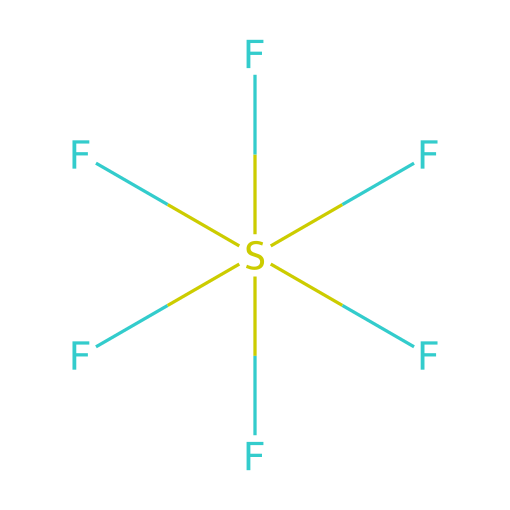What is the name of this chemical? The structure represents a compound with one sulfur atom and six fluorine atoms bonded to it. The distinct arrangement of these atoms corresponds to sulfur hexafluoride.
Answer: sulfur hexafluoride How many fluorine atoms are present? The SMILES representation clearly shows six fluorine atoms surrounding a single sulfur atom. This can be counted directly from the formula.
Answer: six What type of bond exists between sulfur and fluorine? The sulfur atom is covalently bonded to each of the six fluorine atoms, resulting in strong bonds characterized by the sharing of electrons.
Answer: covalent bond What geometry does sulfur hexafluoride exhibit? In sulfur hexafluoride, the arrangement of the six fluorine atoms around the sulfur atom leads to an octahedral geometry, which can be inferred from the bonding pattern.
Answer: octahedral Why is sulfur hexafluoride used in audio equipment? The large molecular size and low reactivity of sulfur hexafluoride contribute to its properties as a dense gas, which is advantageous in sound effects and insulation in audio applications.
Answer: dense gas Is sulfur hexafluoride polar or nonpolar? The symmetrical arrangement of the fluorine atoms around the sulfur atom creates a nonpolar molecule, as the dipoles cancel out due to symmetry.
Answer: nonpolar 